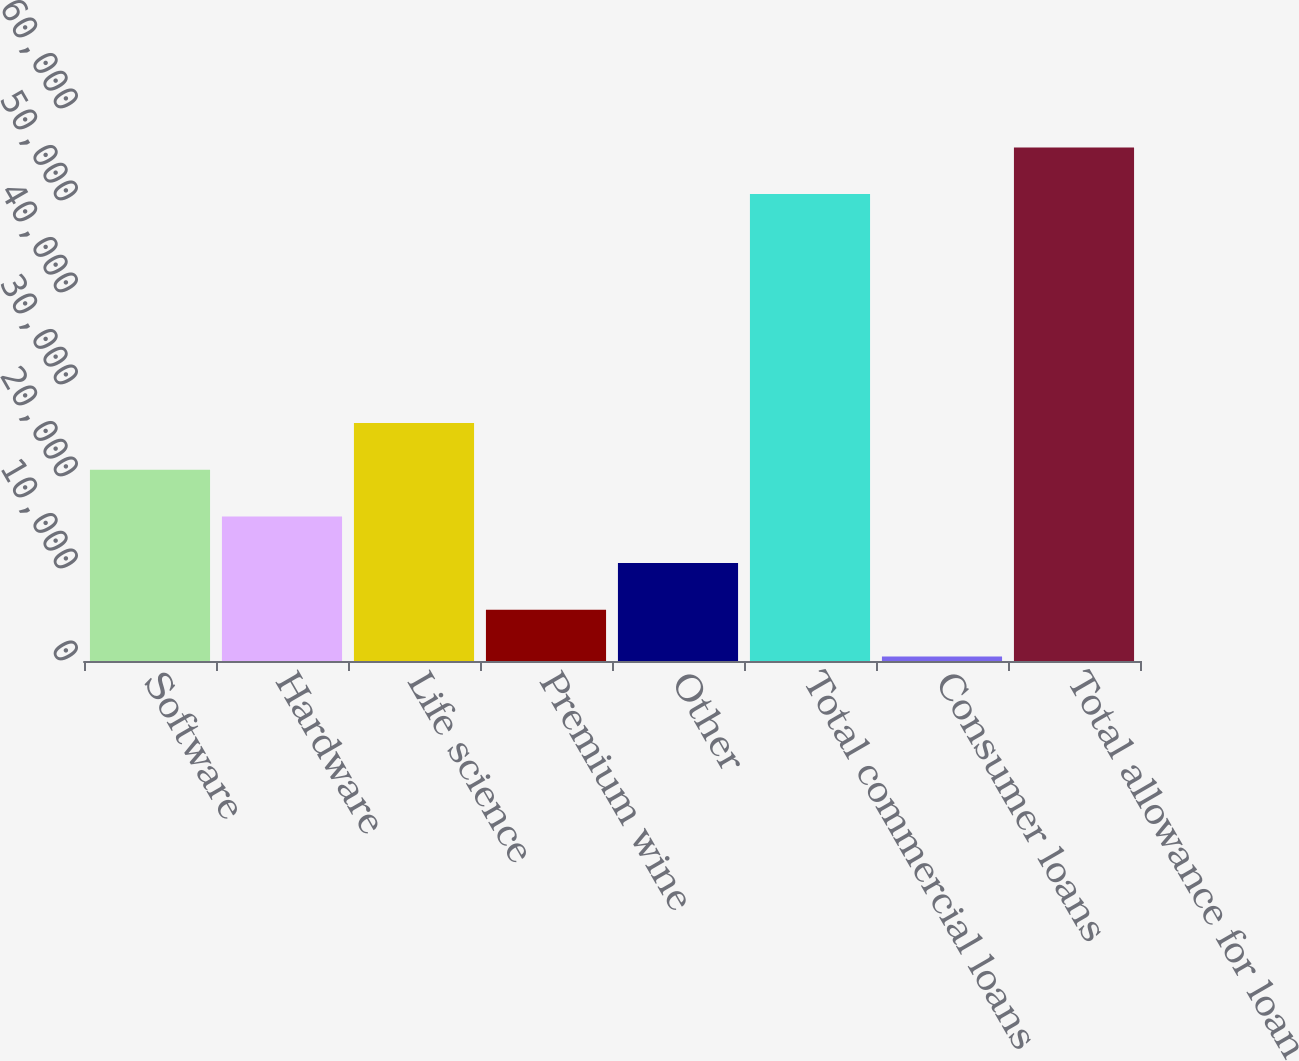Convert chart. <chart><loc_0><loc_0><loc_500><loc_500><bar_chart><fcel>Software<fcel>Hardware<fcel>Life science<fcel>Premium wine<fcel>Other<fcel>Total commercial loans<fcel>Consumer loans<fcel>Total allowance for loan<nl><fcel>20789<fcel>15714<fcel>25864<fcel>5564<fcel>10639<fcel>50750<fcel>489<fcel>55825<nl></chart> 